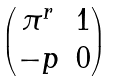Convert formula to latex. <formula><loc_0><loc_0><loc_500><loc_500>\begin{pmatrix} \pi ^ { r } & 1 \\ - p & 0 \\ \end{pmatrix}</formula> 